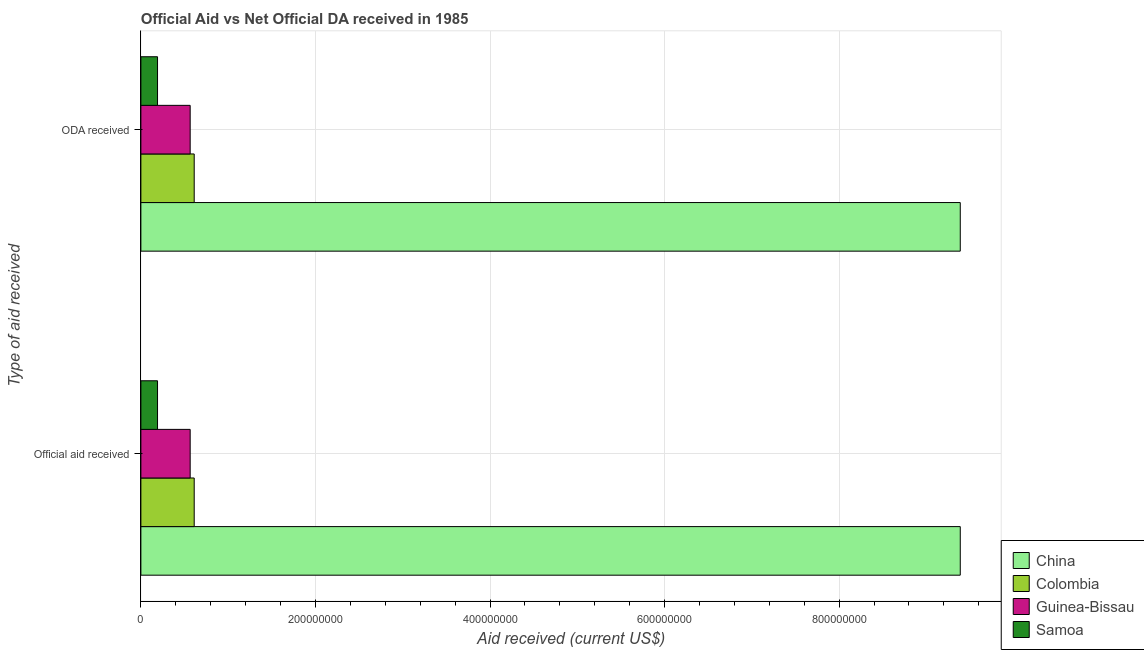How many groups of bars are there?
Your answer should be very brief. 2. Are the number of bars per tick equal to the number of legend labels?
Ensure brevity in your answer.  Yes. How many bars are there on the 1st tick from the top?
Offer a terse response. 4. What is the label of the 2nd group of bars from the top?
Your answer should be very brief. Official aid received. What is the official aid received in Samoa?
Provide a succinct answer. 1.91e+07. Across all countries, what is the maximum official aid received?
Give a very brief answer. 9.39e+08. Across all countries, what is the minimum oda received?
Offer a very short reply. 1.91e+07. In which country was the official aid received minimum?
Make the answer very short. Samoa. What is the total official aid received in the graph?
Your answer should be very brief. 1.08e+09. What is the difference between the official aid received in Samoa and that in China?
Provide a succinct answer. -9.20e+08. What is the difference between the oda received in Guinea-Bissau and the official aid received in Samoa?
Your response must be concise. 3.74e+07. What is the average oda received per country?
Ensure brevity in your answer.  2.69e+08. What is the ratio of the official aid received in Samoa to that in Colombia?
Your answer should be very brief. 0.31. What does the 2nd bar from the top in Official aid received represents?
Make the answer very short. Guinea-Bissau. How many bars are there?
Ensure brevity in your answer.  8. Are all the bars in the graph horizontal?
Make the answer very short. Yes. What is the difference between two consecutive major ticks on the X-axis?
Offer a terse response. 2.00e+08. Are the values on the major ticks of X-axis written in scientific E-notation?
Your response must be concise. No. Does the graph contain any zero values?
Offer a terse response. No. Does the graph contain grids?
Your answer should be very brief. Yes. Where does the legend appear in the graph?
Your answer should be very brief. Bottom right. How many legend labels are there?
Keep it short and to the point. 4. How are the legend labels stacked?
Give a very brief answer. Vertical. What is the title of the graph?
Your response must be concise. Official Aid vs Net Official DA received in 1985 . Does "Maldives" appear as one of the legend labels in the graph?
Offer a terse response. No. What is the label or title of the X-axis?
Ensure brevity in your answer.  Aid received (current US$). What is the label or title of the Y-axis?
Keep it short and to the point. Type of aid received. What is the Aid received (current US$) in China in Official aid received?
Make the answer very short. 9.39e+08. What is the Aid received (current US$) of Colombia in Official aid received?
Provide a short and direct response. 6.11e+07. What is the Aid received (current US$) in Guinea-Bissau in Official aid received?
Provide a succinct answer. 5.65e+07. What is the Aid received (current US$) in Samoa in Official aid received?
Provide a short and direct response. 1.91e+07. What is the Aid received (current US$) in China in ODA received?
Make the answer very short. 9.39e+08. What is the Aid received (current US$) of Colombia in ODA received?
Offer a very short reply. 6.11e+07. What is the Aid received (current US$) in Guinea-Bissau in ODA received?
Your answer should be compact. 5.65e+07. What is the Aid received (current US$) of Samoa in ODA received?
Provide a succinct answer. 1.91e+07. Across all Type of aid received, what is the maximum Aid received (current US$) in China?
Give a very brief answer. 9.39e+08. Across all Type of aid received, what is the maximum Aid received (current US$) in Colombia?
Provide a short and direct response. 6.11e+07. Across all Type of aid received, what is the maximum Aid received (current US$) in Guinea-Bissau?
Offer a very short reply. 5.65e+07. Across all Type of aid received, what is the maximum Aid received (current US$) of Samoa?
Your answer should be compact. 1.91e+07. Across all Type of aid received, what is the minimum Aid received (current US$) of China?
Your answer should be very brief. 9.39e+08. Across all Type of aid received, what is the minimum Aid received (current US$) in Colombia?
Your answer should be compact. 6.11e+07. Across all Type of aid received, what is the minimum Aid received (current US$) in Guinea-Bissau?
Your answer should be very brief. 5.65e+07. Across all Type of aid received, what is the minimum Aid received (current US$) in Samoa?
Your answer should be very brief. 1.91e+07. What is the total Aid received (current US$) of China in the graph?
Provide a short and direct response. 1.88e+09. What is the total Aid received (current US$) in Colombia in the graph?
Give a very brief answer. 1.22e+08. What is the total Aid received (current US$) in Guinea-Bissau in the graph?
Your answer should be compact. 1.13e+08. What is the total Aid received (current US$) in Samoa in the graph?
Your answer should be very brief. 3.81e+07. What is the difference between the Aid received (current US$) of China in Official aid received and that in ODA received?
Your answer should be very brief. 0. What is the difference between the Aid received (current US$) in Colombia in Official aid received and that in ODA received?
Make the answer very short. 0. What is the difference between the Aid received (current US$) of China in Official aid received and the Aid received (current US$) of Colombia in ODA received?
Give a very brief answer. 8.78e+08. What is the difference between the Aid received (current US$) in China in Official aid received and the Aid received (current US$) in Guinea-Bissau in ODA received?
Ensure brevity in your answer.  8.82e+08. What is the difference between the Aid received (current US$) of China in Official aid received and the Aid received (current US$) of Samoa in ODA received?
Provide a succinct answer. 9.20e+08. What is the difference between the Aid received (current US$) in Colombia in Official aid received and the Aid received (current US$) in Guinea-Bissau in ODA received?
Offer a terse response. 4.61e+06. What is the difference between the Aid received (current US$) in Colombia in Official aid received and the Aid received (current US$) in Samoa in ODA received?
Offer a terse response. 4.20e+07. What is the difference between the Aid received (current US$) in Guinea-Bissau in Official aid received and the Aid received (current US$) in Samoa in ODA received?
Your answer should be compact. 3.74e+07. What is the average Aid received (current US$) in China per Type of aid received?
Your answer should be very brief. 9.39e+08. What is the average Aid received (current US$) of Colombia per Type of aid received?
Offer a very short reply. 6.11e+07. What is the average Aid received (current US$) of Guinea-Bissau per Type of aid received?
Ensure brevity in your answer.  5.65e+07. What is the average Aid received (current US$) of Samoa per Type of aid received?
Your answer should be compact. 1.91e+07. What is the difference between the Aid received (current US$) of China and Aid received (current US$) of Colombia in Official aid received?
Your answer should be very brief. 8.78e+08. What is the difference between the Aid received (current US$) of China and Aid received (current US$) of Guinea-Bissau in Official aid received?
Ensure brevity in your answer.  8.82e+08. What is the difference between the Aid received (current US$) of China and Aid received (current US$) of Samoa in Official aid received?
Provide a short and direct response. 9.20e+08. What is the difference between the Aid received (current US$) in Colombia and Aid received (current US$) in Guinea-Bissau in Official aid received?
Your response must be concise. 4.61e+06. What is the difference between the Aid received (current US$) in Colombia and Aid received (current US$) in Samoa in Official aid received?
Provide a short and direct response. 4.20e+07. What is the difference between the Aid received (current US$) of Guinea-Bissau and Aid received (current US$) of Samoa in Official aid received?
Offer a very short reply. 3.74e+07. What is the difference between the Aid received (current US$) of China and Aid received (current US$) of Colombia in ODA received?
Make the answer very short. 8.78e+08. What is the difference between the Aid received (current US$) of China and Aid received (current US$) of Guinea-Bissau in ODA received?
Your answer should be compact. 8.82e+08. What is the difference between the Aid received (current US$) in China and Aid received (current US$) in Samoa in ODA received?
Keep it short and to the point. 9.20e+08. What is the difference between the Aid received (current US$) of Colombia and Aid received (current US$) of Guinea-Bissau in ODA received?
Ensure brevity in your answer.  4.61e+06. What is the difference between the Aid received (current US$) of Colombia and Aid received (current US$) of Samoa in ODA received?
Make the answer very short. 4.20e+07. What is the difference between the Aid received (current US$) in Guinea-Bissau and Aid received (current US$) in Samoa in ODA received?
Give a very brief answer. 3.74e+07. What is the ratio of the Aid received (current US$) in China in Official aid received to that in ODA received?
Offer a terse response. 1. What is the difference between the highest and the second highest Aid received (current US$) in China?
Ensure brevity in your answer.  0. What is the difference between the highest and the second highest Aid received (current US$) of Guinea-Bissau?
Give a very brief answer. 0. What is the difference between the highest and the lowest Aid received (current US$) in Colombia?
Your answer should be compact. 0. 